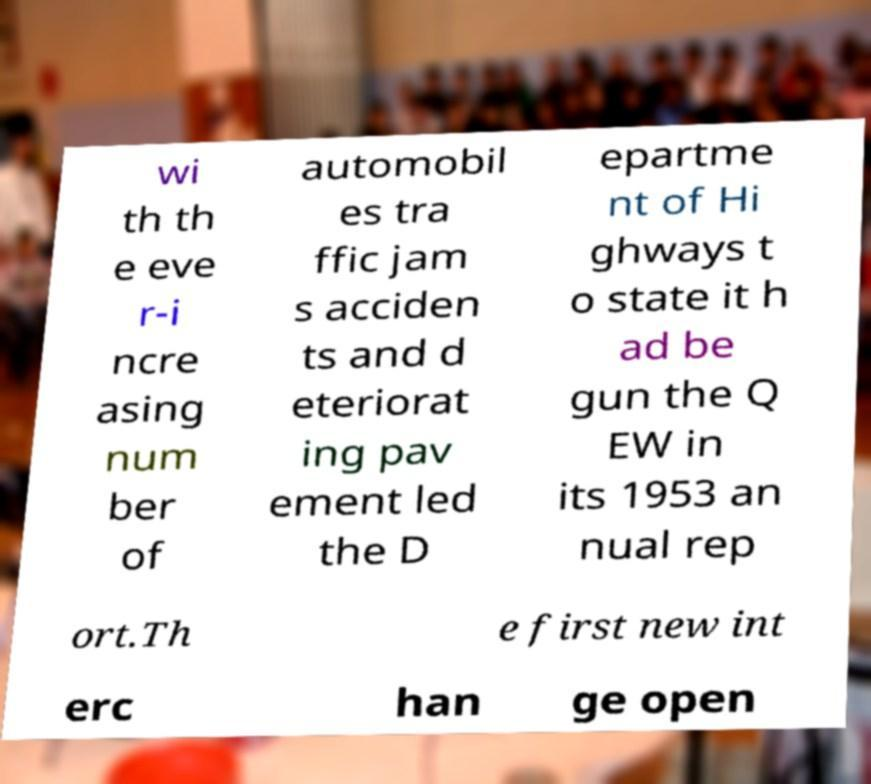There's text embedded in this image that I need extracted. Can you transcribe it verbatim? wi th th e eve r-i ncre asing num ber of automobil es tra ffic jam s acciden ts and d eteriorat ing pav ement led the D epartme nt of Hi ghways t o state it h ad be gun the Q EW in its 1953 an nual rep ort.Th e first new int erc han ge open 